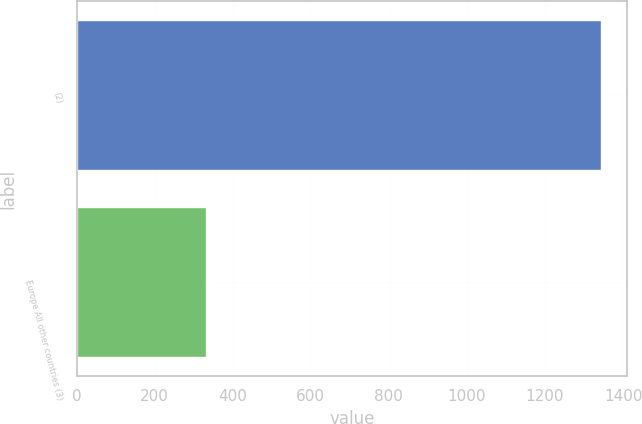Convert chart. <chart><loc_0><loc_0><loc_500><loc_500><bar_chart><fcel>(2)<fcel>Europe All other countries (3)<nl><fcel>1343.6<fcel>330.3<nl></chart> 